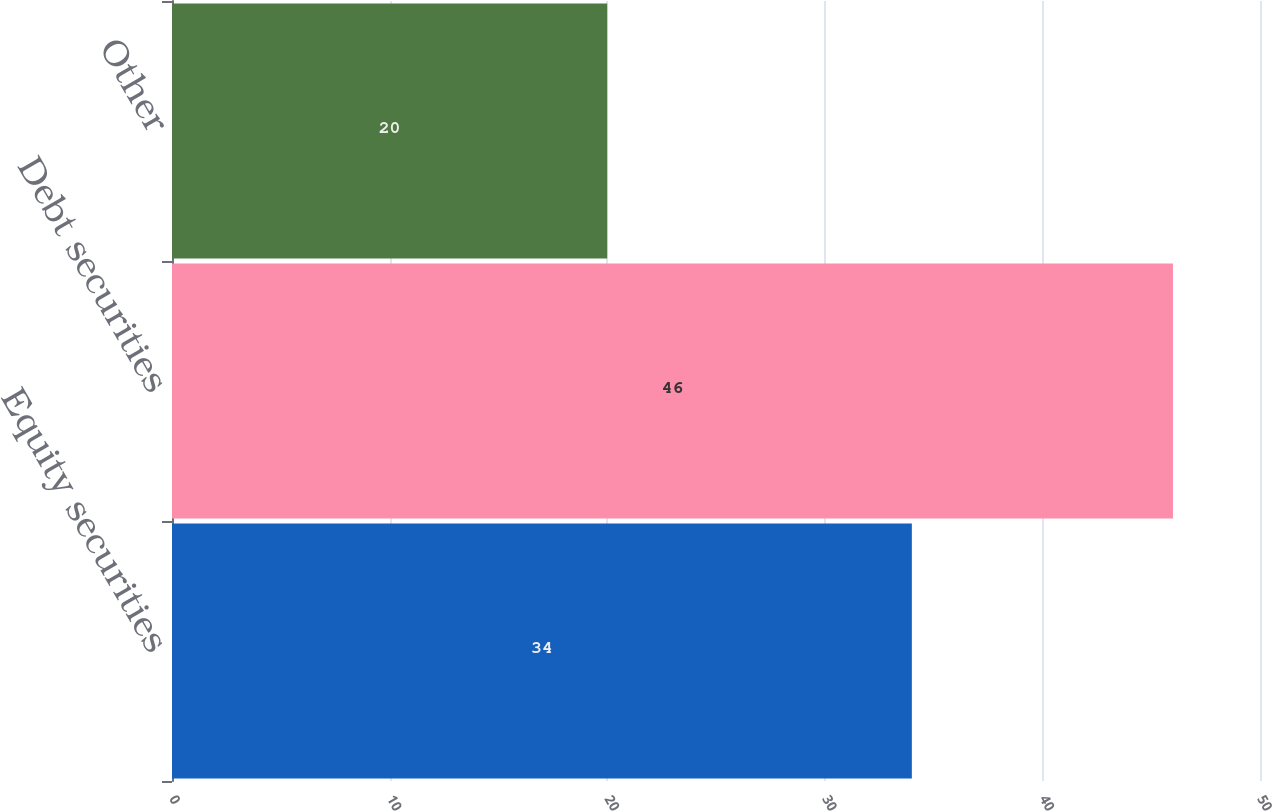Convert chart to OTSL. <chart><loc_0><loc_0><loc_500><loc_500><bar_chart><fcel>Equity securities<fcel>Debt securities<fcel>Other<nl><fcel>34<fcel>46<fcel>20<nl></chart> 